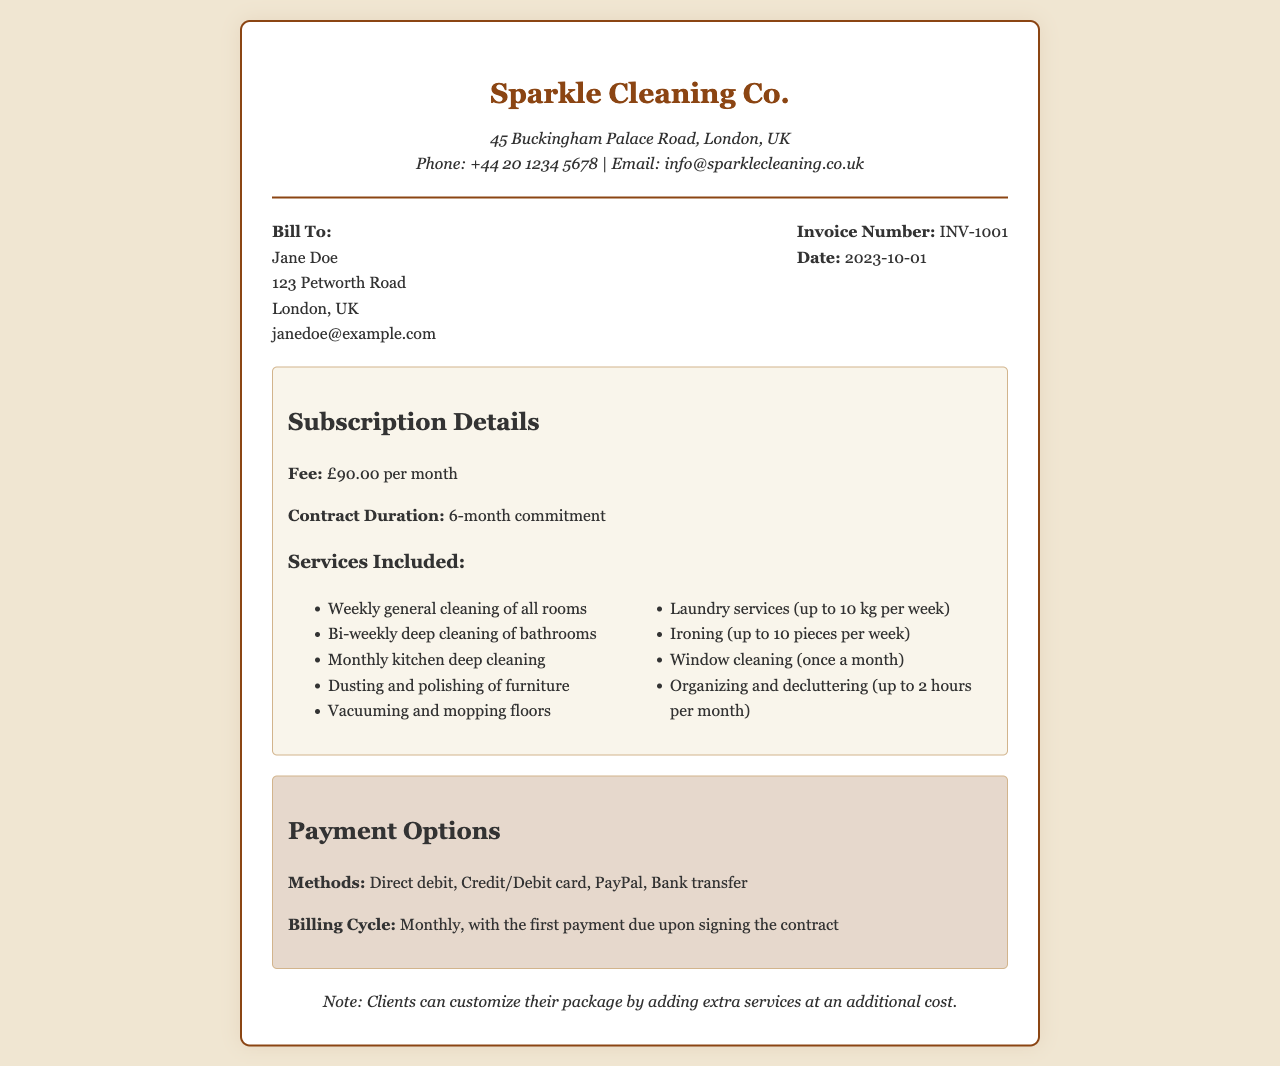what is the monthly subscription fee? The monthly subscription fee is specified in the subscription details section of the document.
Answer: £90.00 per month how long is the contract duration? The document states the contract duration in the subscription details section.
Answer: 6-month commitment how many pieces of laundry are included per week? The document mentions the laundry services limit in the services included section.
Answer: up to 10 kg per week what types of payment methods are accepted? The payment options section lists the methods available for payment.
Answer: Direct debit, Credit/Debit card, PayPal, Bank transfer what is the invoice number? The invoice number is clearly shown in the client info section of the document.
Answer: INV-1001 which service is provided once a month? This service is mentioned in the services included list, specifying its frequency.
Answer: Window cleaning (once a month) how often is deep cleaning of bathrooms conducted? The frequency of this service is indicated in the services included section.
Answer: Bi-weekly what is the first payment due condition? This condition is found in the payment options section of the document.
Answer: upon signing the contract 